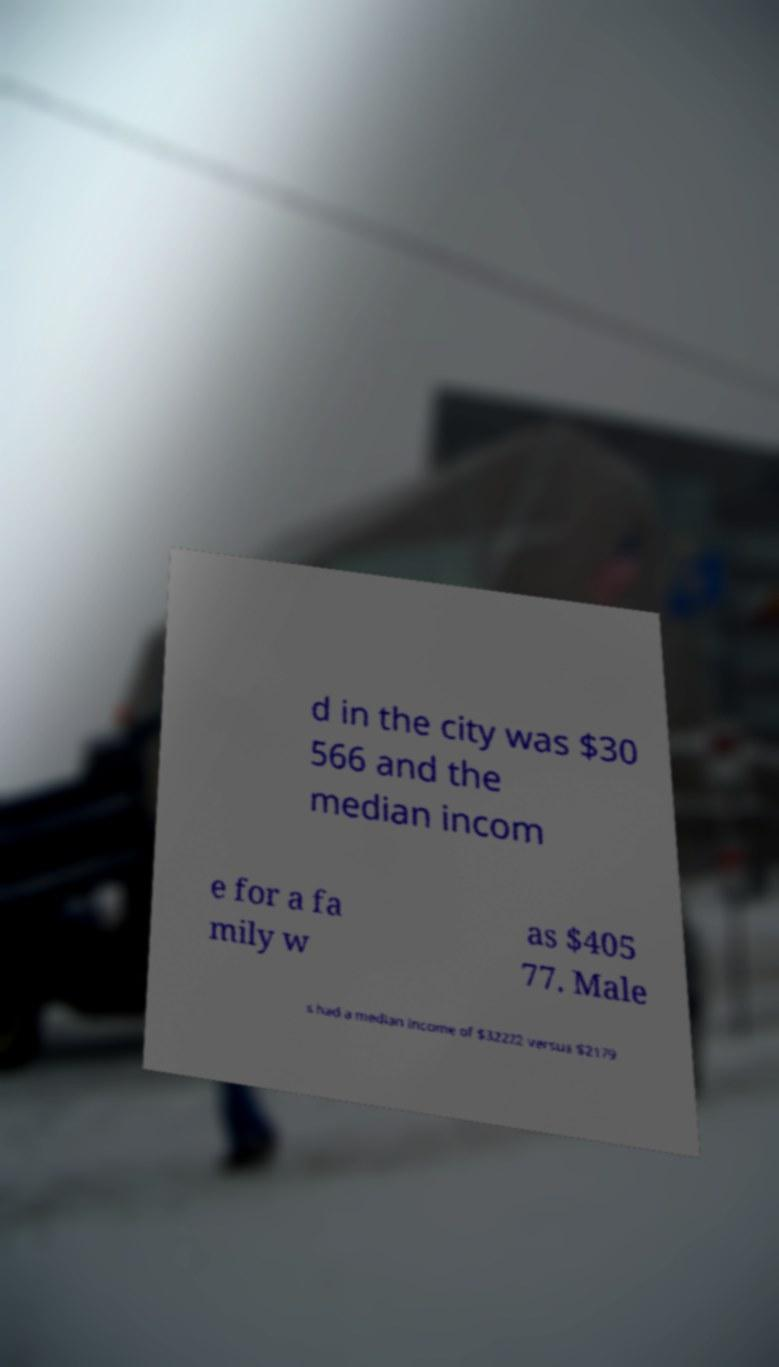What messages or text are displayed in this image? I need them in a readable, typed format. d in the city was $30 566 and the median incom e for a fa mily w as $405 77. Male s had a median income of $32222 versus $2179 